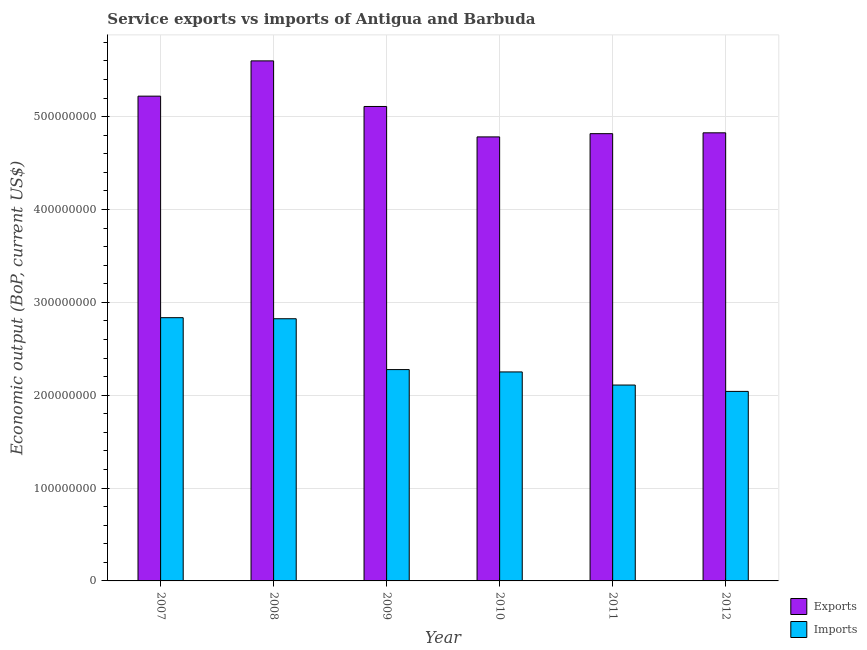How many different coloured bars are there?
Give a very brief answer. 2. What is the amount of service imports in 2010?
Your response must be concise. 2.25e+08. Across all years, what is the maximum amount of service exports?
Keep it short and to the point. 5.60e+08. Across all years, what is the minimum amount of service exports?
Your answer should be very brief. 4.78e+08. What is the total amount of service imports in the graph?
Provide a short and direct response. 1.43e+09. What is the difference between the amount of service exports in 2008 and that in 2009?
Make the answer very short. 4.91e+07. What is the difference between the amount of service imports in 2010 and the amount of service exports in 2007?
Keep it short and to the point. -5.84e+07. What is the average amount of service exports per year?
Keep it short and to the point. 5.06e+08. In the year 2010, what is the difference between the amount of service imports and amount of service exports?
Give a very brief answer. 0. What is the ratio of the amount of service exports in 2008 to that in 2011?
Provide a short and direct response. 1.16. Is the amount of service exports in 2007 less than that in 2009?
Give a very brief answer. No. What is the difference between the highest and the second highest amount of service exports?
Offer a very short reply. 3.80e+07. What is the difference between the highest and the lowest amount of service exports?
Provide a succinct answer. 8.19e+07. What does the 2nd bar from the left in 2012 represents?
Ensure brevity in your answer.  Imports. What does the 1st bar from the right in 2011 represents?
Offer a very short reply. Imports. What is the difference between two consecutive major ticks on the Y-axis?
Ensure brevity in your answer.  1.00e+08. Are the values on the major ticks of Y-axis written in scientific E-notation?
Keep it short and to the point. No. Does the graph contain any zero values?
Your answer should be very brief. No. What is the title of the graph?
Your answer should be compact. Service exports vs imports of Antigua and Barbuda. What is the label or title of the Y-axis?
Provide a succinct answer. Economic output (BoP, current US$). What is the Economic output (BoP, current US$) of Exports in 2007?
Offer a terse response. 5.22e+08. What is the Economic output (BoP, current US$) of Imports in 2007?
Keep it short and to the point. 2.83e+08. What is the Economic output (BoP, current US$) of Exports in 2008?
Ensure brevity in your answer.  5.60e+08. What is the Economic output (BoP, current US$) in Imports in 2008?
Your response must be concise. 2.82e+08. What is the Economic output (BoP, current US$) in Exports in 2009?
Provide a succinct answer. 5.11e+08. What is the Economic output (BoP, current US$) of Imports in 2009?
Offer a terse response. 2.28e+08. What is the Economic output (BoP, current US$) in Exports in 2010?
Provide a short and direct response. 4.78e+08. What is the Economic output (BoP, current US$) of Imports in 2010?
Offer a very short reply. 2.25e+08. What is the Economic output (BoP, current US$) of Exports in 2011?
Offer a very short reply. 4.82e+08. What is the Economic output (BoP, current US$) in Imports in 2011?
Keep it short and to the point. 2.11e+08. What is the Economic output (BoP, current US$) in Exports in 2012?
Make the answer very short. 4.83e+08. What is the Economic output (BoP, current US$) in Imports in 2012?
Your response must be concise. 2.04e+08. Across all years, what is the maximum Economic output (BoP, current US$) of Exports?
Ensure brevity in your answer.  5.60e+08. Across all years, what is the maximum Economic output (BoP, current US$) in Imports?
Your answer should be compact. 2.83e+08. Across all years, what is the minimum Economic output (BoP, current US$) of Exports?
Provide a short and direct response. 4.78e+08. Across all years, what is the minimum Economic output (BoP, current US$) of Imports?
Make the answer very short. 2.04e+08. What is the total Economic output (BoP, current US$) in Exports in the graph?
Make the answer very short. 3.04e+09. What is the total Economic output (BoP, current US$) of Imports in the graph?
Your answer should be compact. 1.43e+09. What is the difference between the Economic output (BoP, current US$) in Exports in 2007 and that in 2008?
Offer a very short reply. -3.80e+07. What is the difference between the Economic output (BoP, current US$) in Imports in 2007 and that in 2008?
Provide a succinct answer. 1.14e+06. What is the difference between the Economic output (BoP, current US$) in Exports in 2007 and that in 2009?
Your answer should be compact. 1.11e+07. What is the difference between the Economic output (BoP, current US$) of Imports in 2007 and that in 2009?
Provide a short and direct response. 5.59e+07. What is the difference between the Economic output (BoP, current US$) of Exports in 2007 and that in 2010?
Your answer should be very brief. 4.39e+07. What is the difference between the Economic output (BoP, current US$) of Imports in 2007 and that in 2010?
Your answer should be very brief. 5.84e+07. What is the difference between the Economic output (BoP, current US$) of Exports in 2007 and that in 2011?
Keep it short and to the point. 4.04e+07. What is the difference between the Economic output (BoP, current US$) of Imports in 2007 and that in 2011?
Provide a short and direct response. 7.25e+07. What is the difference between the Economic output (BoP, current US$) in Exports in 2007 and that in 2012?
Your answer should be very brief. 3.95e+07. What is the difference between the Economic output (BoP, current US$) of Imports in 2007 and that in 2012?
Your answer should be very brief. 7.94e+07. What is the difference between the Economic output (BoP, current US$) in Exports in 2008 and that in 2009?
Provide a short and direct response. 4.91e+07. What is the difference between the Economic output (BoP, current US$) in Imports in 2008 and that in 2009?
Give a very brief answer. 5.48e+07. What is the difference between the Economic output (BoP, current US$) in Exports in 2008 and that in 2010?
Offer a terse response. 8.19e+07. What is the difference between the Economic output (BoP, current US$) of Imports in 2008 and that in 2010?
Provide a succinct answer. 5.73e+07. What is the difference between the Economic output (BoP, current US$) of Exports in 2008 and that in 2011?
Make the answer very short. 7.84e+07. What is the difference between the Economic output (BoP, current US$) in Imports in 2008 and that in 2011?
Offer a very short reply. 7.14e+07. What is the difference between the Economic output (BoP, current US$) in Exports in 2008 and that in 2012?
Offer a very short reply. 7.75e+07. What is the difference between the Economic output (BoP, current US$) in Imports in 2008 and that in 2012?
Your response must be concise. 7.82e+07. What is the difference between the Economic output (BoP, current US$) of Exports in 2009 and that in 2010?
Your answer should be very brief. 3.28e+07. What is the difference between the Economic output (BoP, current US$) of Imports in 2009 and that in 2010?
Offer a terse response. 2.52e+06. What is the difference between the Economic output (BoP, current US$) of Exports in 2009 and that in 2011?
Provide a succinct answer. 2.93e+07. What is the difference between the Economic output (BoP, current US$) of Imports in 2009 and that in 2011?
Ensure brevity in your answer.  1.66e+07. What is the difference between the Economic output (BoP, current US$) in Exports in 2009 and that in 2012?
Give a very brief answer. 2.84e+07. What is the difference between the Economic output (BoP, current US$) in Imports in 2009 and that in 2012?
Provide a short and direct response. 2.35e+07. What is the difference between the Economic output (BoP, current US$) in Exports in 2010 and that in 2011?
Your response must be concise. -3.49e+06. What is the difference between the Economic output (BoP, current US$) in Imports in 2010 and that in 2011?
Offer a very short reply. 1.41e+07. What is the difference between the Economic output (BoP, current US$) in Exports in 2010 and that in 2012?
Keep it short and to the point. -4.39e+06. What is the difference between the Economic output (BoP, current US$) of Imports in 2010 and that in 2012?
Offer a terse response. 2.10e+07. What is the difference between the Economic output (BoP, current US$) in Exports in 2011 and that in 2012?
Offer a very short reply. -9.03e+05. What is the difference between the Economic output (BoP, current US$) in Imports in 2011 and that in 2012?
Keep it short and to the point. 6.84e+06. What is the difference between the Economic output (BoP, current US$) in Exports in 2007 and the Economic output (BoP, current US$) in Imports in 2008?
Ensure brevity in your answer.  2.40e+08. What is the difference between the Economic output (BoP, current US$) in Exports in 2007 and the Economic output (BoP, current US$) in Imports in 2009?
Ensure brevity in your answer.  2.94e+08. What is the difference between the Economic output (BoP, current US$) in Exports in 2007 and the Economic output (BoP, current US$) in Imports in 2010?
Your response must be concise. 2.97e+08. What is the difference between the Economic output (BoP, current US$) in Exports in 2007 and the Economic output (BoP, current US$) in Imports in 2011?
Provide a succinct answer. 3.11e+08. What is the difference between the Economic output (BoP, current US$) of Exports in 2007 and the Economic output (BoP, current US$) of Imports in 2012?
Keep it short and to the point. 3.18e+08. What is the difference between the Economic output (BoP, current US$) in Exports in 2008 and the Economic output (BoP, current US$) in Imports in 2009?
Offer a terse response. 3.32e+08. What is the difference between the Economic output (BoP, current US$) in Exports in 2008 and the Economic output (BoP, current US$) in Imports in 2010?
Keep it short and to the point. 3.35e+08. What is the difference between the Economic output (BoP, current US$) of Exports in 2008 and the Economic output (BoP, current US$) of Imports in 2011?
Keep it short and to the point. 3.49e+08. What is the difference between the Economic output (BoP, current US$) in Exports in 2008 and the Economic output (BoP, current US$) in Imports in 2012?
Keep it short and to the point. 3.56e+08. What is the difference between the Economic output (BoP, current US$) in Exports in 2009 and the Economic output (BoP, current US$) in Imports in 2010?
Offer a terse response. 2.86e+08. What is the difference between the Economic output (BoP, current US$) in Exports in 2009 and the Economic output (BoP, current US$) in Imports in 2011?
Make the answer very short. 3.00e+08. What is the difference between the Economic output (BoP, current US$) in Exports in 2009 and the Economic output (BoP, current US$) in Imports in 2012?
Ensure brevity in your answer.  3.07e+08. What is the difference between the Economic output (BoP, current US$) in Exports in 2010 and the Economic output (BoP, current US$) in Imports in 2011?
Provide a short and direct response. 2.67e+08. What is the difference between the Economic output (BoP, current US$) in Exports in 2010 and the Economic output (BoP, current US$) in Imports in 2012?
Your answer should be very brief. 2.74e+08. What is the difference between the Economic output (BoP, current US$) of Exports in 2011 and the Economic output (BoP, current US$) of Imports in 2012?
Offer a very short reply. 2.78e+08. What is the average Economic output (BoP, current US$) of Exports per year?
Keep it short and to the point. 5.06e+08. What is the average Economic output (BoP, current US$) of Imports per year?
Keep it short and to the point. 2.39e+08. In the year 2007, what is the difference between the Economic output (BoP, current US$) in Exports and Economic output (BoP, current US$) in Imports?
Offer a terse response. 2.39e+08. In the year 2008, what is the difference between the Economic output (BoP, current US$) of Exports and Economic output (BoP, current US$) of Imports?
Keep it short and to the point. 2.78e+08. In the year 2009, what is the difference between the Economic output (BoP, current US$) of Exports and Economic output (BoP, current US$) of Imports?
Keep it short and to the point. 2.83e+08. In the year 2010, what is the difference between the Economic output (BoP, current US$) of Exports and Economic output (BoP, current US$) of Imports?
Ensure brevity in your answer.  2.53e+08. In the year 2011, what is the difference between the Economic output (BoP, current US$) in Exports and Economic output (BoP, current US$) in Imports?
Keep it short and to the point. 2.71e+08. In the year 2012, what is the difference between the Economic output (BoP, current US$) of Exports and Economic output (BoP, current US$) of Imports?
Keep it short and to the point. 2.78e+08. What is the ratio of the Economic output (BoP, current US$) in Exports in 2007 to that in 2008?
Offer a very short reply. 0.93. What is the ratio of the Economic output (BoP, current US$) of Exports in 2007 to that in 2009?
Keep it short and to the point. 1.02. What is the ratio of the Economic output (BoP, current US$) of Imports in 2007 to that in 2009?
Make the answer very short. 1.25. What is the ratio of the Economic output (BoP, current US$) in Exports in 2007 to that in 2010?
Your answer should be compact. 1.09. What is the ratio of the Economic output (BoP, current US$) of Imports in 2007 to that in 2010?
Keep it short and to the point. 1.26. What is the ratio of the Economic output (BoP, current US$) in Exports in 2007 to that in 2011?
Ensure brevity in your answer.  1.08. What is the ratio of the Economic output (BoP, current US$) in Imports in 2007 to that in 2011?
Your response must be concise. 1.34. What is the ratio of the Economic output (BoP, current US$) of Exports in 2007 to that in 2012?
Give a very brief answer. 1.08. What is the ratio of the Economic output (BoP, current US$) of Imports in 2007 to that in 2012?
Provide a succinct answer. 1.39. What is the ratio of the Economic output (BoP, current US$) in Exports in 2008 to that in 2009?
Keep it short and to the point. 1.1. What is the ratio of the Economic output (BoP, current US$) of Imports in 2008 to that in 2009?
Keep it short and to the point. 1.24. What is the ratio of the Economic output (BoP, current US$) of Exports in 2008 to that in 2010?
Your answer should be compact. 1.17. What is the ratio of the Economic output (BoP, current US$) in Imports in 2008 to that in 2010?
Provide a succinct answer. 1.25. What is the ratio of the Economic output (BoP, current US$) of Exports in 2008 to that in 2011?
Provide a succinct answer. 1.16. What is the ratio of the Economic output (BoP, current US$) of Imports in 2008 to that in 2011?
Keep it short and to the point. 1.34. What is the ratio of the Economic output (BoP, current US$) of Exports in 2008 to that in 2012?
Provide a short and direct response. 1.16. What is the ratio of the Economic output (BoP, current US$) in Imports in 2008 to that in 2012?
Ensure brevity in your answer.  1.38. What is the ratio of the Economic output (BoP, current US$) in Exports in 2009 to that in 2010?
Give a very brief answer. 1.07. What is the ratio of the Economic output (BoP, current US$) of Imports in 2009 to that in 2010?
Offer a very short reply. 1.01. What is the ratio of the Economic output (BoP, current US$) in Exports in 2009 to that in 2011?
Offer a very short reply. 1.06. What is the ratio of the Economic output (BoP, current US$) of Imports in 2009 to that in 2011?
Give a very brief answer. 1.08. What is the ratio of the Economic output (BoP, current US$) of Exports in 2009 to that in 2012?
Ensure brevity in your answer.  1.06. What is the ratio of the Economic output (BoP, current US$) in Imports in 2009 to that in 2012?
Give a very brief answer. 1.12. What is the ratio of the Economic output (BoP, current US$) of Imports in 2010 to that in 2011?
Your response must be concise. 1.07. What is the ratio of the Economic output (BoP, current US$) in Exports in 2010 to that in 2012?
Make the answer very short. 0.99. What is the ratio of the Economic output (BoP, current US$) in Imports in 2010 to that in 2012?
Ensure brevity in your answer.  1.1. What is the ratio of the Economic output (BoP, current US$) in Imports in 2011 to that in 2012?
Offer a terse response. 1.03. What is the difference between the highest and the second highest Economic output (BoP, current US$) of Exports?
Your response must be concise. 3.80e+07. What is the difference between the highest and the second highest Economic output (BoP, current US$) in Imports?
Offer a terse response. 1.14e+06. What is the difference between the highest and the lowest Economic output (BoP, current US$) in Exports?
Ensure brevity in your answer.  8.19e+07. What is the difference between the highest and the lowest Economic output (BoP, current US$) in Imports?
Offer a terse response. 7.94e+07. 